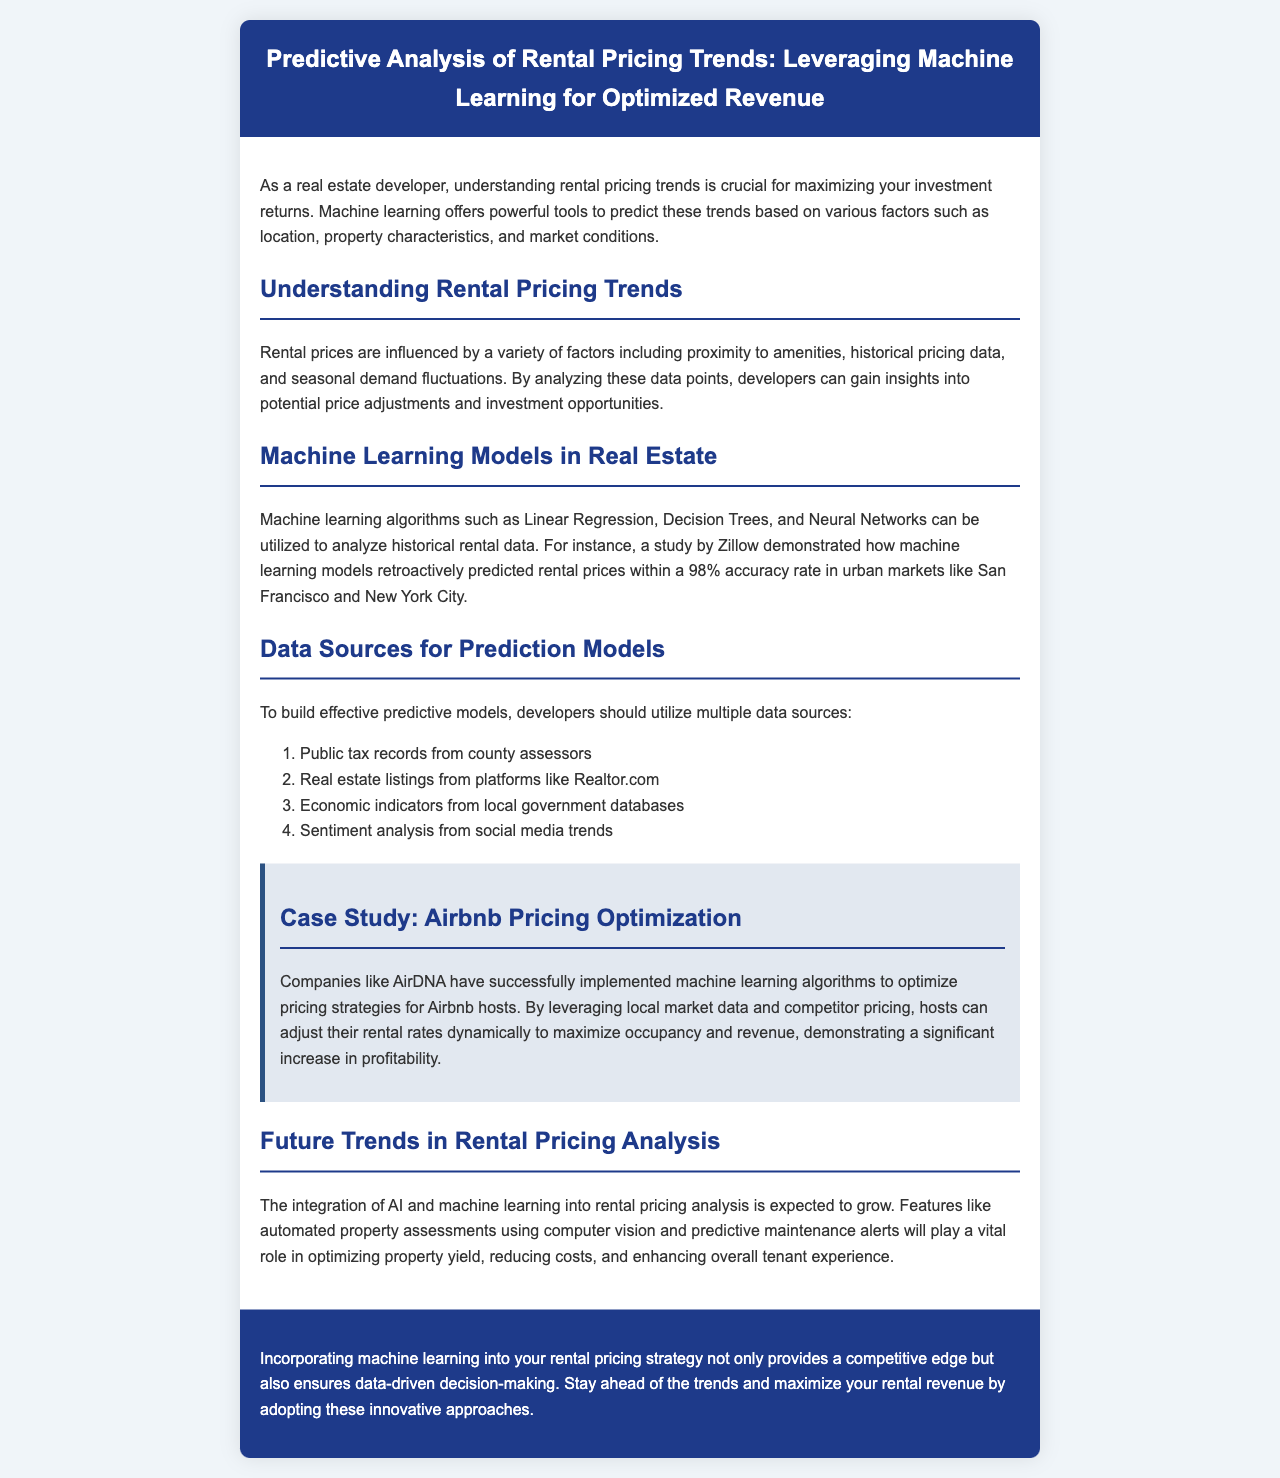What is the main focus of the newsletter? The newsletter focuses on predictive analysis of rental pricing trends using machine learning for optimized revenue.
Answer: Predictive analysis of rental pricing trends What type of algorithms are mentioned for analyzing rental data? The newsletter lists algorithms such as Linear Regression, Decision Trees, and Neural Networks for analyzing rental data.
Answer: Linear Regression, Decision Trees, Neural Networks Which case study is referenced in the document? The newsletter describes a case study related to Airbnb pricing optimization by companies like AirDNA.
Answer: Airbnb pricing optimization What is the predicted accuracy rate of the machine learning models mentioned? The text states that the machine learning models predicted rental prices with a 98% accuracy rate.
Answer: 98% How many data sources are recommended for building predictive models? The newsletter recommends utilizing four data sources to build effective predictive models.
Answer: Four What is one future trend in rental pricing analysis noted in the document? The newsletter mentions that features like automated property assessments using computer vision will be part of future trends in rental pricing analysis.
Answer: Automated property assessments Which city markets were highlighted for retroactive predictions? The document highlights urban markets such as San Francisco and New York City for retroactive predictions of rental prices.
Answer: San Francisco and New York City What is the conclusion of the newsletter regarding machine learning? The newsletter concludes that incorporating machine learning into rental pricing strategy provides a competitive edge.
Answer: Competitive edge 